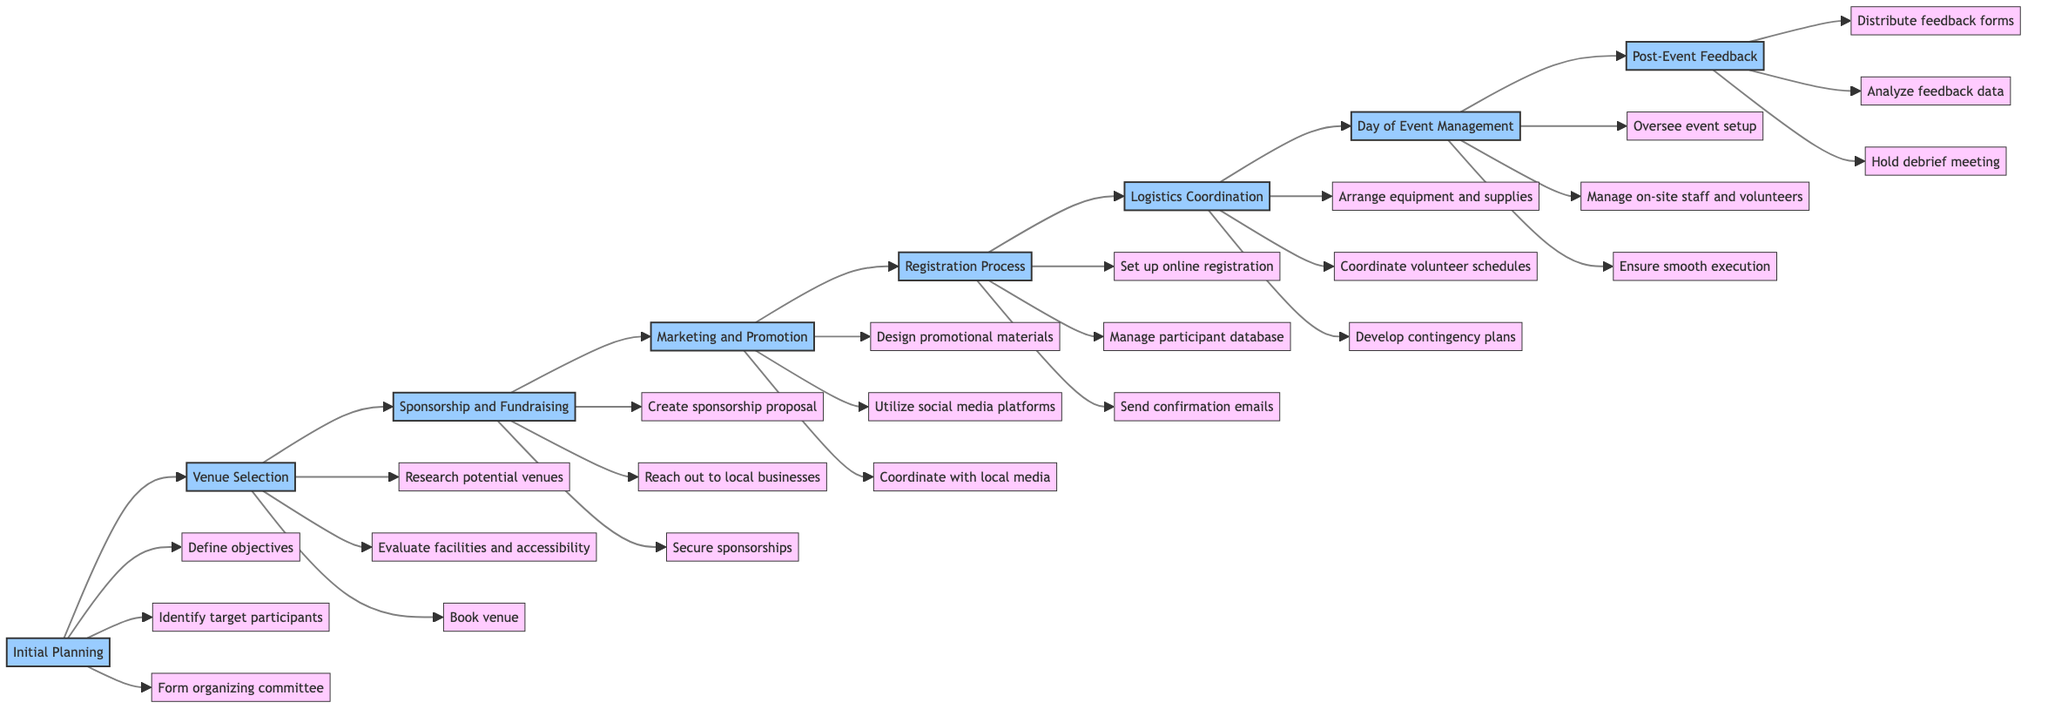What is the first step in organizing a community sports event? The flowchart shows that the first step listed is "Initial Planning." It is the starting point of the diagram and directly leads to the next step.
Answer: Initial Planning How many tasks are listed under "Logistics Coordination"? Looking at the flowchart, the box for "Logistics Coordination" has three tasks connected to it: "Arrange equipment and supplies," "Coordinate volunteer schedules," and "Develop contingency plans." Thus, there are three tasks in total.
Answer: 3 What follows "Sponsorship and Fundraising"? The flowchart indicates that "Marketing and Promotion" is the next step after "Sponsorship and Fundraising." The diagram connects these two steps directly in the horizontal flow.
Answer: Marketing and Promotion What are the main objectives of the "Initial Planning" step? The diagram connects three tasks to "Initial Planning": "Define objectives," "Identify target participants," and "Form organizing committee." These tasks outline the primary focuses of this step.
Answer: Define objectives, Identify target participants, Form organizing committee Which step involves sending confirmation emails? The flowchart illustrates that the task of sending confirmation emails is part of the "Registration Process." This is shown by the direct connection from "Registration Process" to the task labeled "Send confirmation emails."
Answer: Registration Process What is the last step in the organization of the event? Referring to the flowchart, the last step listed is "Post-Event Feedback." This step follows the entire progression of tasks and marks the conclusion of the process.
Answer: Post-Event Feedback How many main steps are involved in the entire process? Counting the steps illustrated in the diagram, there are eight main steps, all arranged in a horizontal flow from "Initial Planning" to "Post-Event Feedback."
Answer: 8 What type of feedback is collected after the event? The flowchart shows that "Distribute feedback forms" is one of the tasks under "Post-Event Feedback," indicating this is how feedback is collected post-event.
Answer: Feedback forms Which two steps directly involve communication with businesses? The diagram indicates that "Reach out to local businesses" is one task in "Sponsorship and Fundraising," and the task "Coordinate with local media" is found in "Marketing and Promotion." Both steps involve external communication.
Answer: Sponsorship and Fundraising, Marketing and Promotion 